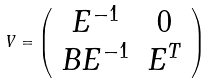<formula> <loc_0><loc_0><loc_500><loc_500>V = \left ( \begin{array} { c c } E ^ { - 1 } & 0 \\ B E ^ { - 1 } & E ^ { T } \end{array} \right )</formula> 